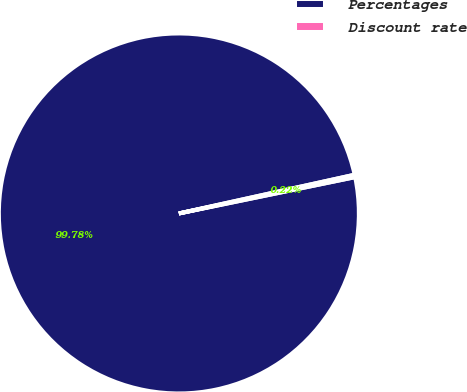<chart> <loc_0><loc_0><loc_500><loc_500><pie_chart><fcel>Percentages<fcel>Discount rate<nl><fcel>99.78%<fcel>0.22%<nl></chart> 